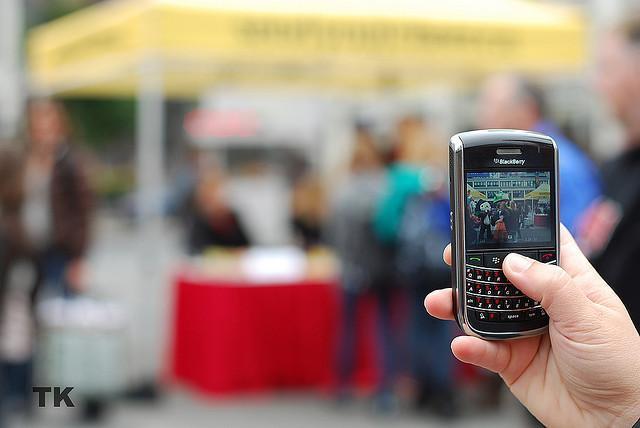How many people are in the photo?
Give a very brief answer. 8. 